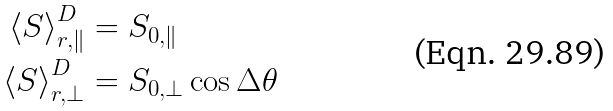<formula> <loc_0><loc_0><loc_500><loc_500>\left \langle S \right \rangle _ { r , \| } ^ { D } & = S _ { 0 , \| } \\ \left \langle S \right \rangle _ { r , \perp } ^ { D } & = S _ { 0 , \perp } \cos \Delta \theta</formula> 